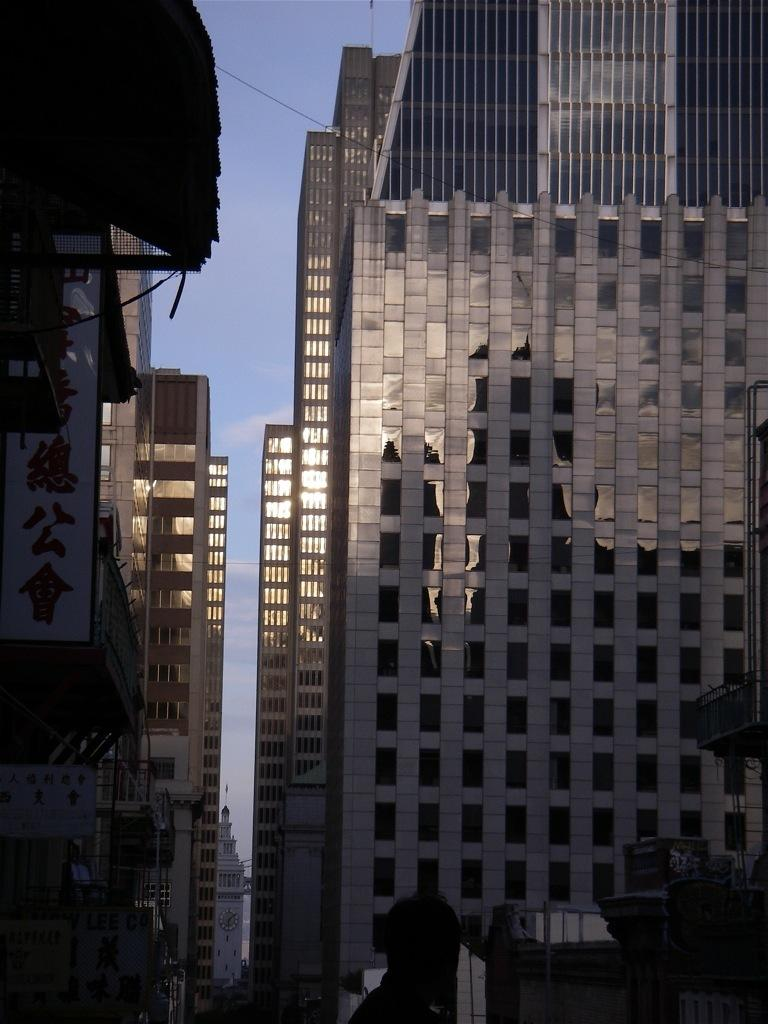Who or what is present in the image? There is a person in the image. What can be seen in the background of the image? There are glass buildings in the background of the image. What is visible in the sky in the image? There are clouds in the sky, and the sky is blue. How many fowl are present in the image? There are no fowl present in the image. What type of grass can be seen in the image? There is no grass visible in the image; it features a person and glass buildings in the background. 